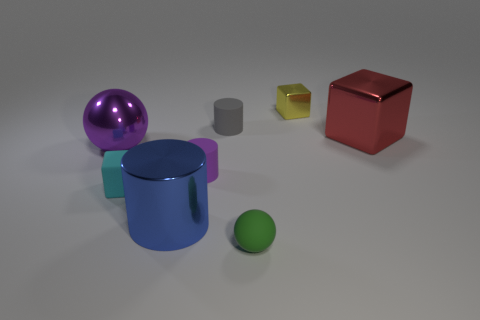Subtract all metallic blocks. How many blocks are left? 1 Subtract 1 cylinders. How many cylinders are left? 2 Add 2 big red things. How many objects exist? 10 Subtract 0 gray blocks. How many objects are left? 8 Subtract all cylinders. How many objects are left? 5 Subtract all blue metallic spheres. Subtract all red shiny things. How many objects are left? 7 Add 5 small yellow objects. How many small yellow objects are left? 6 Add 1 tiny rubber balls. How many tiny rubber balls exist? 2 